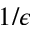<formula> <loc_0><loc_0><loc_500><loc_500>1 / \epsilon</formula> 